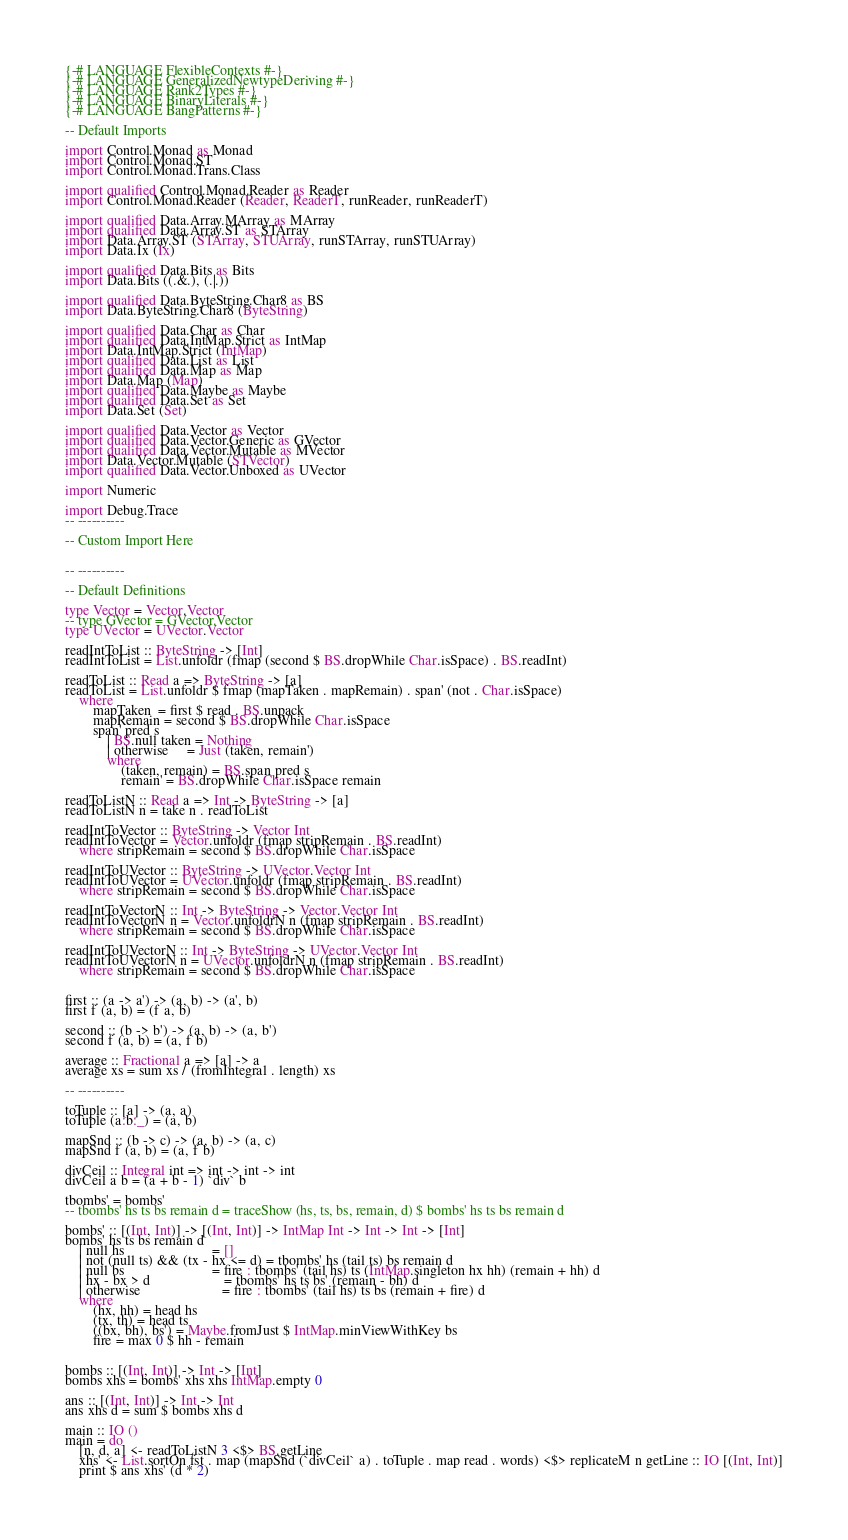Convert code to text. <code><loc_0><loc_0><loc_500><loc_500><_Haskell_>{-# LANGUAGE FlexibleContexts #-}
{-# LANGUAGE GeneralizedNewtypeDeriving #-}
{-# LANGUAGE Rank2Types #-}
{-# LANGUAGE BinaryLiterals #-}
{-# LANGUAGE BangPatterns #-}

-- Default Imports

import Control.Monad as Monad
import Control.Monad.ST
import Control.Monad.Trans.Class

import qualified Control.Monad.Reader as Reader
import Control.Monad.Reader (Reader, ReaderT, runReader, runReaderT)

import qualified Data.Array.MArray as MArray
import qualified Data.Array.ST as STArray
import Data.Array.ST (STArray, STUArray, runSTArray, runSTUArray)
import Data.Ix (Ix)

import qualified Data.Bits as Bits
import Data.Bits ((.&.), (.|.))

import qualified Data.ByteString.Char8 as BS
import Data.ByteString.Char8 (ByteString)

import qualified Data.Char as Char
import qualified Data.IntMap.Strict as IntMap
import Data.IntMap.Strict (IntMap)
import qualified Data.List as List
import qualified Data.Map as Map
import Data.Map (Map)
import qualified Data.Maybe as Maybe
import qualified Data.Set as Set
import Data.Set (Set)

import qualified Data.Vector as Vector
import qualified Data.Vector.Generic as GVector
import qualified Data.Vector.Mutable as MVector
import Data.Vector.Mutable (STVector)
import qualified Data.Vector.Unboxed as UVector

import Numeric

import Debug.Trace
-- ----------

-- Custom Import Here


-- ----------

-- Default Definitions

type Vector = Vector.Vector
-- type GVector = GVector.Vector
type UVector = UVector.Vector

readIntToList :: ByteString -> [Int]
readIntToList = List.unfoldr (fmap (second $ BS.dropWhile Char.isSpace) . BS.readInt)

readToList :: Read a => ByteString -> [a]
readToList = List.unfoldr $ fmap (mapTaken . mapRemain) . span' (not . Char.isSpace)
	where
		mapTaken  = first $ read . BS.unpack
		mapRemain = second $ BS.dropWhile Char.isSpace
		span' pred s
			| BS.null taken = Nothing
			| otherwise     = Just (taken, remain')
			where
				(taken, remain) = BS.span pred s
				remain' = BS.dropWhile Char.isSpace remain

readToListN :: Read a => Int -> ByteString -> [a]
readToListN n = take n . readToList

readIntToVector :: ByteString -> Vector Int
readIntToVector = Vector.unfoldr (fmap stripRemain . BS.readInt)
	where stripRemain = second $ BS.dropWhile Char.isSpace

readIntToUVector :: ByteString -> UVector.Vector Int
readIntToUVector = UVector.unfoldr (fmap stripRemain . BS.readInt)
	where stripRemain = second $ BS.dropWhile Char.isSpace

readIntToVectorN :: Int -> ByteString -> Vector.Vector Int
readIntToVectorN n = Vector.unfoldrN n (fmap stripRemain . BS.readInt)
	where stripRemain = second $ BS.dropWhile Char.isSpace

readIntToUVectorN :: Int -> ByteString -> UVector.Vector Int
readIntToUVectorN n = UVector.unfoldrN n (fmap stripRemain . BS.readInt)
	where stripRemain = second $ BS.dropWhile Char.isSpace


first :: (a -> a') -> (a, b) -> (a', b)
first f (a, b) = (f a, b)

second :: (b -> b') -> (a, b) -> (a, b')
second f (a, b) = (a, f b)

average :: Fractional a => [a] -> a
average xs = sum xs / (fromIntegral . length) xs

-- ----------

toTuple :: [a] -> (a, a)
toTuple (a:b:_) = (a, b)

mapSnd :: (b -> c) -> (a, b) -> (a, c)
mapSnd f (a, b) = (a, f b)

divCeil :: Integral int => int -> int -> int
divCeil a b = (a + b - 1) `div` b

tbombs' = bombs'
-- tbombs' hs ts bs remain d = traceShow (hs, ts, bs, remain, d) $ bombs' hs ts bs remain d

bombs' :: [(Int, Int)] -> [(Int, Int)] -> IntMap Int -> Int -> Int -> [Int]
bombs' hs ts bs remain d
	| null hs                         = []
	| not (null ts) && (tx - hx <= d) = tbombs' hs (tail ts) bs remain d
	| null bs                         = fire : tbombs' (tail hs) ts (IntMap.singleton hx hh) (remain + hh) d
	| hx - bx > d                     = tbombs' hs ts bs' (remain - bh) d
	| otherwise                       = fire : tbombs' (tail hs) ts bs (remain + fire) d
	where
		(hx, hh) = head hs
		(tx, th) = head ts
		((bx, bh), bs') = Maybe.fromJust $ IntMap.minViewWithKey bs
		fire = max 0 $ hh - remain


bombs :: [(Int, Int)] -> Int -> [Int]
bombs xhs = bombs' xhs xhs IntMap.empty 0

ans :: [(Int, Int)] -> Int -> Int
ans xhs d = sum $ bombs xhs d

main :: IO ()
main = do
	[n, d, a] <- readToListN 3 <$> BS.getLine
	xhs' <- List.sortOn fst . map (mapSnd (`divCeil` a) . toTuple . map read . words) <$> replicateM n getLine :: IO [(Int, Int)]
	print $ ans xhs' (d * 2)
</code> 